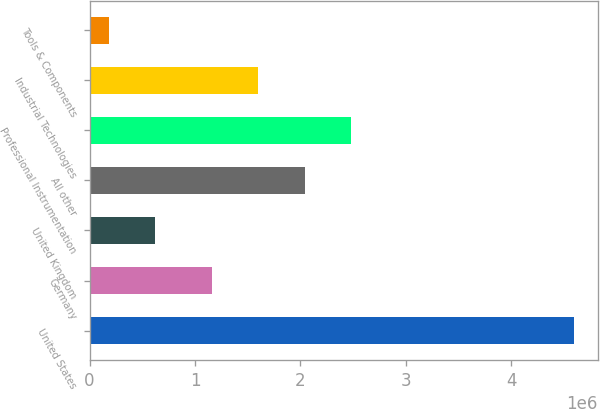Convert chart. <chart><loc_0><loc_0><loc_500><loc_500><bar_chart><fcel>United States<fcel>Germany<fcel>United Kingdom<fcel>All other<fcel>Professional Instrumentation<fcel>Industrial Technologies<fcel>Tools & Components<nl><fcel>4.59299e+06<fcel>1.16064e+06<fcel>622401<fcel>2.04299e+06<fcel>2.48417e+06<fcel>1.60181e+06<fcel>181224<nl></chart> 